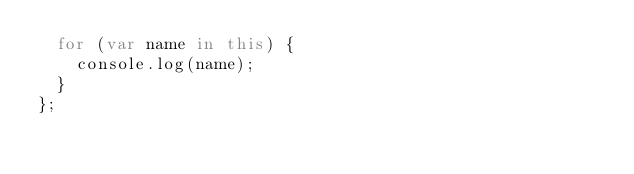<code> <loc_0><loc_0><loc_500><loc_500><_JavaScript_>  for (var name in this) {
    console.log(name);
  }
};
</code> 